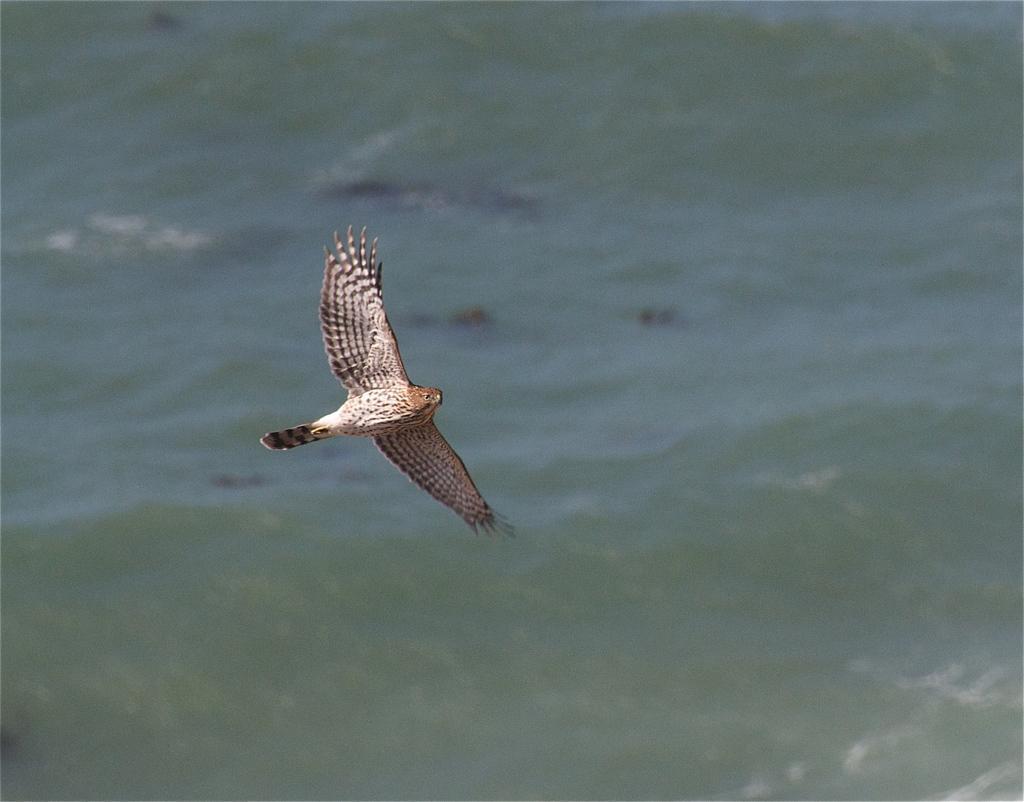Please provide a concise description of this image. In the image there is a bird flying in the air, in the back it's an ocean. 